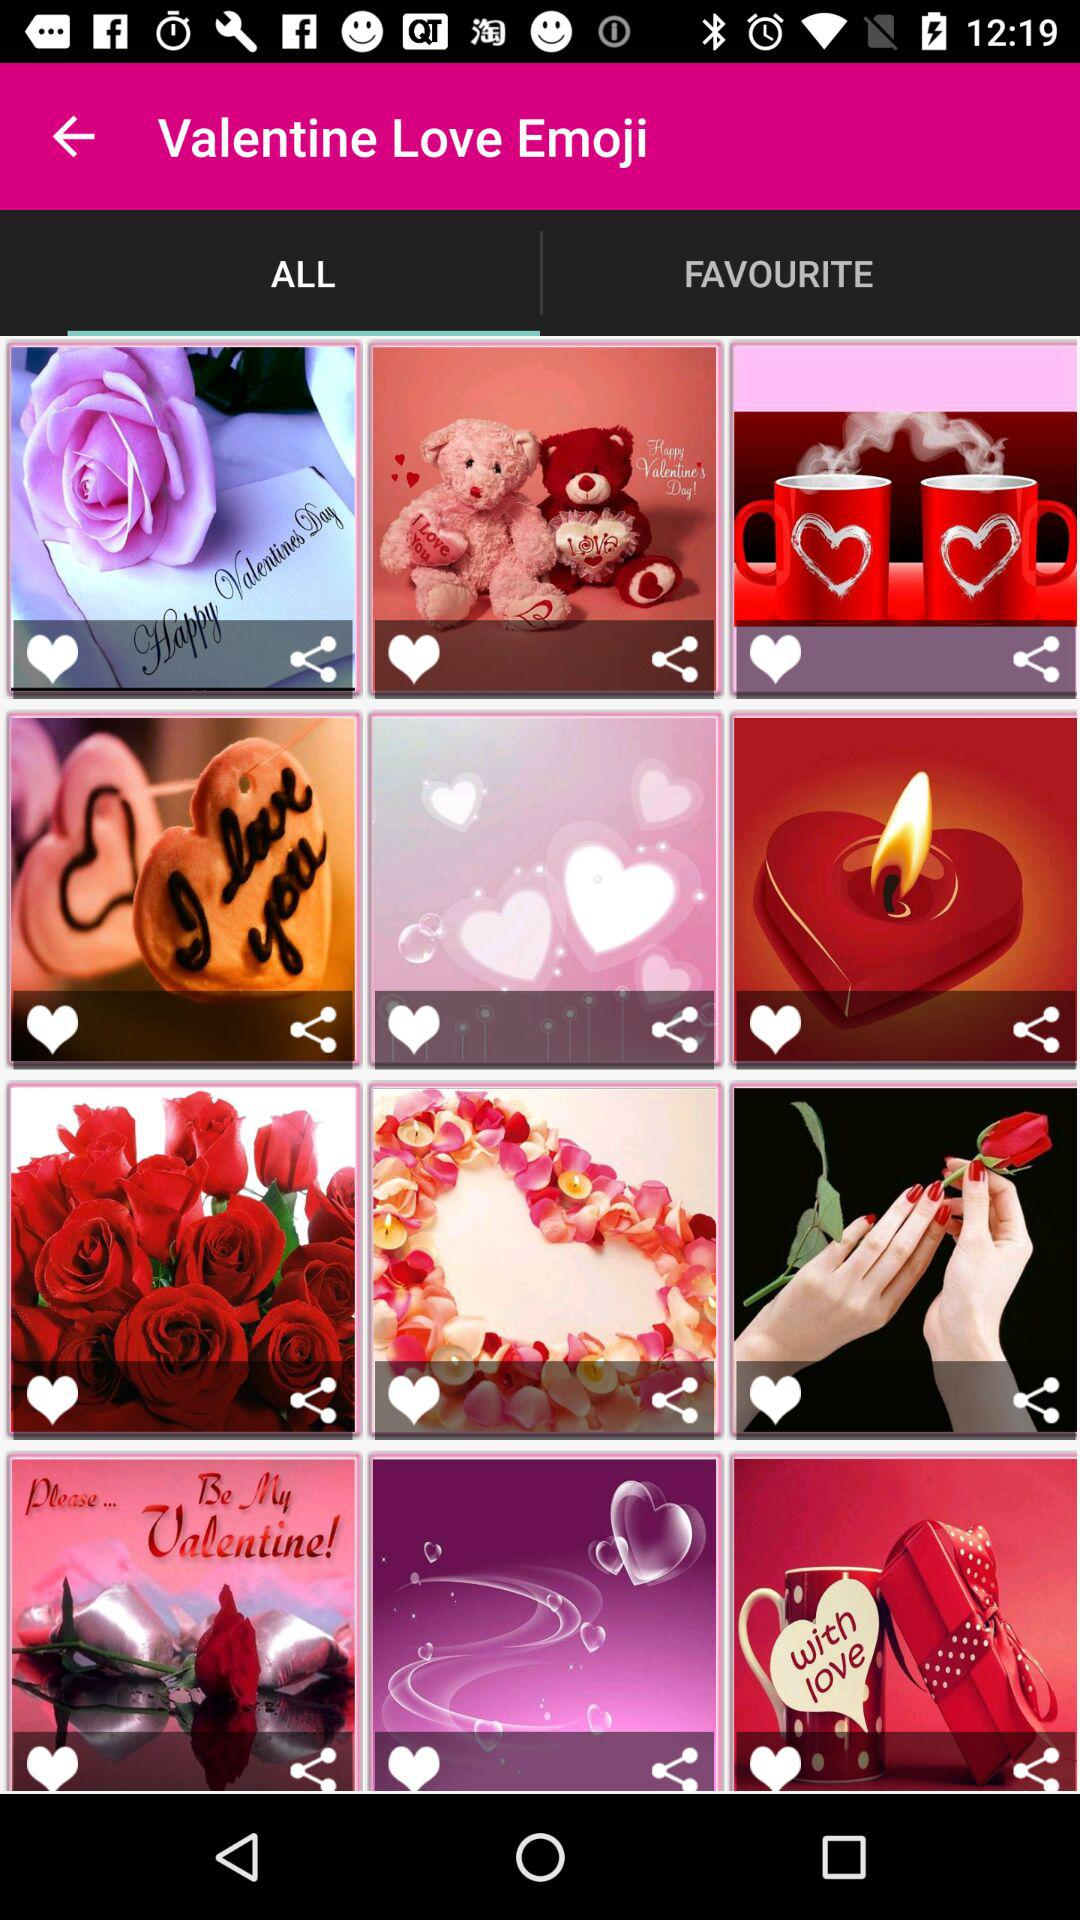Which tab am I on? You are on the "ALL" tab. 